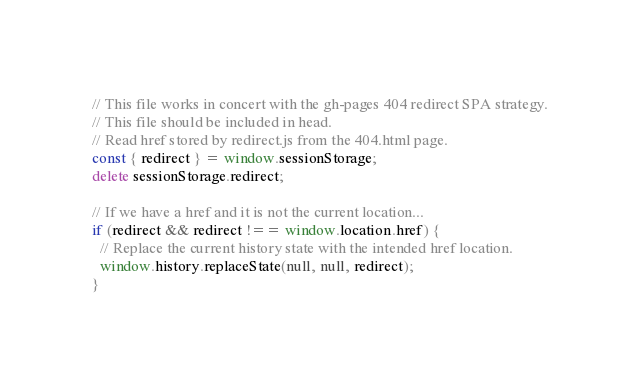<code> <loc_0><loc_0><loc_500><loc_500><_JavaScript_>// This file works in concert with the gh-pages 404 redirect SPA strategy.
// This file should be included in head.
// Read href stored by redirect.js from the 404.html page.
const { redirect } = window.sessionStorage;
delete sessionStorage.redirect;

// If we have a href and it is not the current location...
if (redirect && redirect !== window.location.href) {
  // Replace the current history state with the intended href location.
  window.history.replaceState(null, null, redirect);
}
</code> 